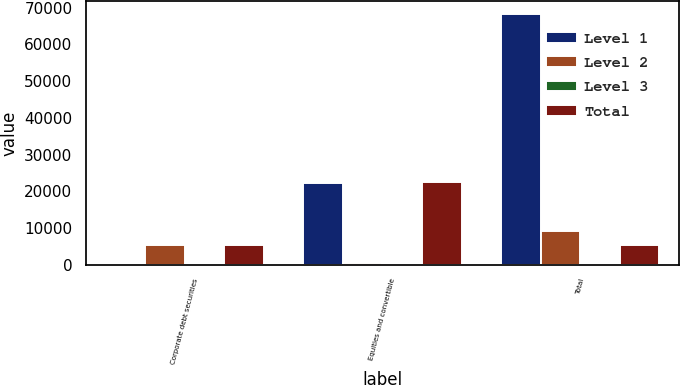Convert chart to OTSL. <chart><loc_0><loc_0><loc_500><loc_500><stacked_bar_chart><ecel><fcel>Corporate debt securities<fcel>Equities and convertible<fcel>Total<nl><fcel>Level 1<fcel>10<fcel>22107<fcel>68313<nl><fcel>Level 2<fcel>5241<fcel>468<fcel>9094<nl><fcel>Level 3<fcel>2<fcel>8<fcel>297<nl><fcel>Total<fcel>5253<fcel>22583<fcel>5241<nl></chart> 